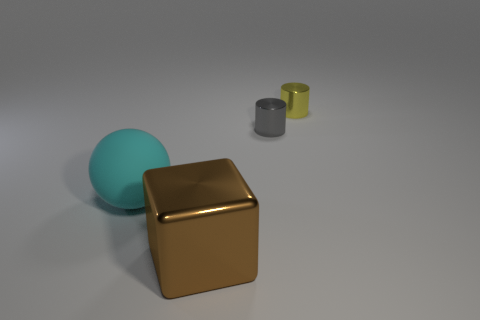Add 2 tiny gray objects. How many objects exist? 6 Subtract all balls. How many objects are left? 3 Subtract 0 gray spheres. How many objects are left? 4 Subtract all brown balls. Subtract all yellow cylinders. How many balls are left? 1 Subtract all tiny matte things. Subtract all spheres. How many objects are left? 3 Add 4 big spheres. How many big spheres are left? 5 Add 1 large metal things. How many large metal things exist? 2 